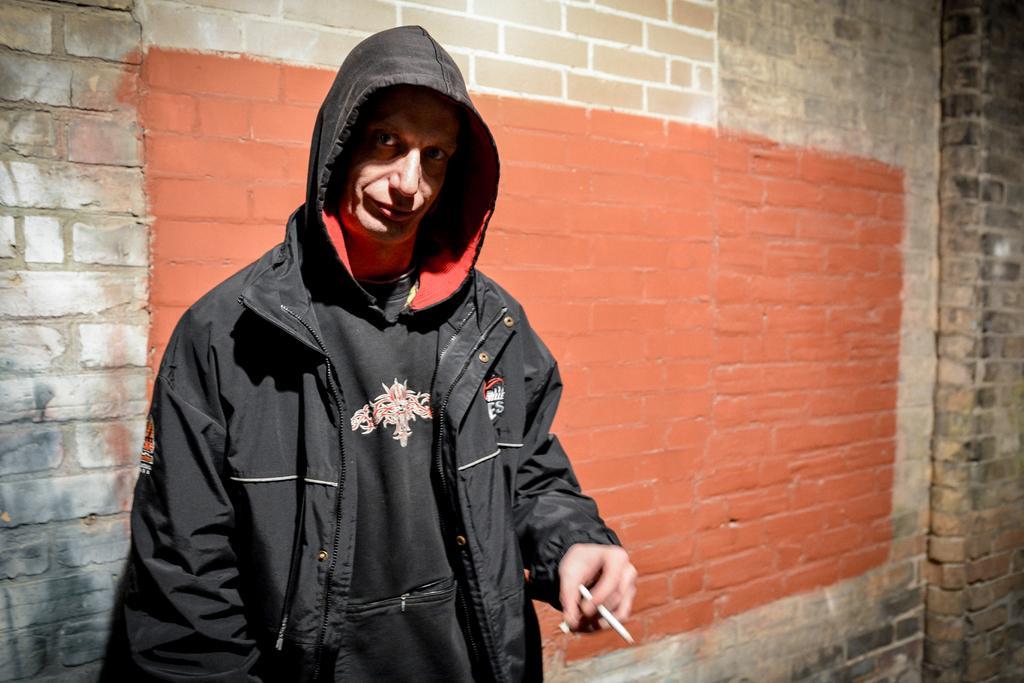Could you give a brief overview of what you see in this image? In this image in the front there is a person standing and holding an object. In the background there is a wall. 